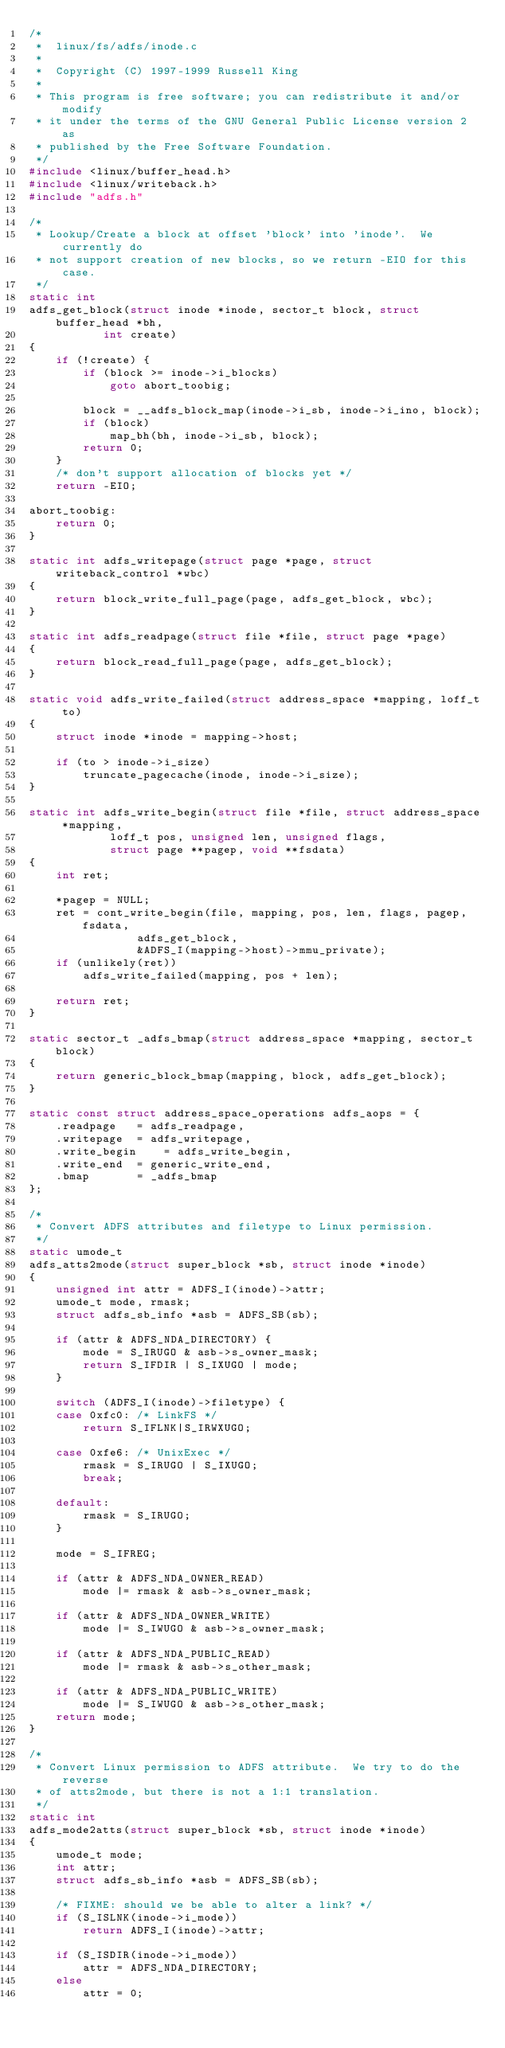Convert code to text. <code><loc_0><loc_0><loc_500><loc_500><_C_>/*
 *  linux/fs/adfs/inode.c
 *
 *  Copyright (C) 1997-1999 Russell King
 *
 * This program is free software; you can redistribute it and/or modify
 * it under the terms of the GNU General Public License version 2 as
 * published by the Free Software Foundation.
 */
#include <linux/buffer_head.h>
#include <linux/writeback.h>
#include "adfs.h"

/*
 * Lookup/Create a block at offset 'block' into 'inode'.  We currently do
 * not support creation of new blocks, so we return -EIO for this case.
 */
static int
adfs_get_block(struct inode *inode, sector_t block, struct buffer_head *bh,
	       int create)
{
	if (!create) {
		if (block >= inode->i_blocks)
			goto abort_toobig;

		block = __adfs_block_map(inode->i_sb, inode->i_ino, block);
		if (block)
			map_bh(bh, inode->i_sb, block);
		return 0;
	}
	/* don't support allocation of blocks yet */
	return -EIO;

abort_toobig:
	return 0;
}

static int adfs_writepage(struct page *page, struct writeback_control *wbc)
{
	return block_write_full_page(page, adfs_get_block, wbc);
}

static int adfs_readpage(struct file *file, struct page *page)
{
	return block_read_full_page(page, adfs_get_block);
}

static void adfs_write_failed(struct address_space *mapping, loff_t to)
{
	struct inode *inode = mapping->host;

	if (to > inode->i_size)
		truncate_pagecache(inode, inode->i_size);
}

static int adfs_write_begin(struct file *file, struct address_space *mapping,
			loff_t pos, unsigned len, unsigned flags,
			struct page **pagep, void **fsdata)
{
	int ret;

	*pagep = NULL;
	ret = cont_write_begin(file, mapping, pos, len, flags, pagep, fsdata,
				adfs_get_block,
				&ADFS_I(mapping->host)->mmu_private);
	if (unlikely(ret))
		adfs_write_failed(mapping, pos + len);

	return ret;
}

static sector_t _adfs_bmap(struct address_space *mapping, sector_t block)
{
	return generic_block_bmap(mapping, block, adfs_get_block);
}

static const struct address_space_operations adfs_aops = {
	.readpage	= adfs_readpage,
	.writepage	= adfs_writepage,
	.write_begin	= adfs_write_begin,
	.write_end	= generic_write_end,
	.bmap		= _adfs_bmap
};

/*
 * Convert ADFS attributes and filetype to Linux permission.
 */
static umode_t
adfs_atts2mode(struct super_block *sb, struct inode *inode)
{
	unsigned int attr = ADFS_I(inode)->attr;
	umode_t mode, rmask;
	struct adfs_sb_info *asb = ADFS_SB(sb);

	if (attr & ADFS_NDA_DIRECTORY) {
		mode = S_IRUGO & asb->s_owner_mask;
		return S_IFDIR | S_IXUGO | mode;
	}

	switch (ADFS_I(inode)->filetype) {
	case 0xfc0:	/* LinkFS */
		return S_IFLNK|S_IRWXUGO;

	case 0xfe6:	/* UnixExec */
		rmask = S_IRUGO | S_IXUGO;
		break;

	default:
		rmask = S_IRUGO;
	}

	mode = S_IFREG;

	if (attr & ADFS_NDA_OWNER_READ)
		mode |= rmask & asb->s_owner_mask;

	if (attr & ADFS_NDA_OWNER_WRITE)
		mode |= S_IWUGO & asb->s_owner_mask;

	if (attr & ADFS_NDA_PUBLIC_READ)
		mode |= rmask & asb->s_other_mask;

	if (attr & ADFS_NDA_PUBLIC_WRITE)
		mode |= S_IWUGO & asb->s_other_mask;
	return mode;
}

/*
 * Convert Linux permission to ADFS attribute.  We try to do the reverse
 * of atts2mode, but there is not a 1:1 translation.
 */
static int
adfs_mode2atts(struct super_block *sb, struct inode *inode)
{
	umode_t mode;
	int attr;
	struct adfs_sb_info *asb = ADFS_SB(sb);

	/* FIXME: should we be able to alter a link? */
	if (S_ISLNK(inode->i_mode))
		return ADFS_I(inode)->attr;

	if (S_ISDIR(inode->i_mode))
		attr = ADFS_NDA_DIRECTORY;
	else
		attr = 0;
</code> 